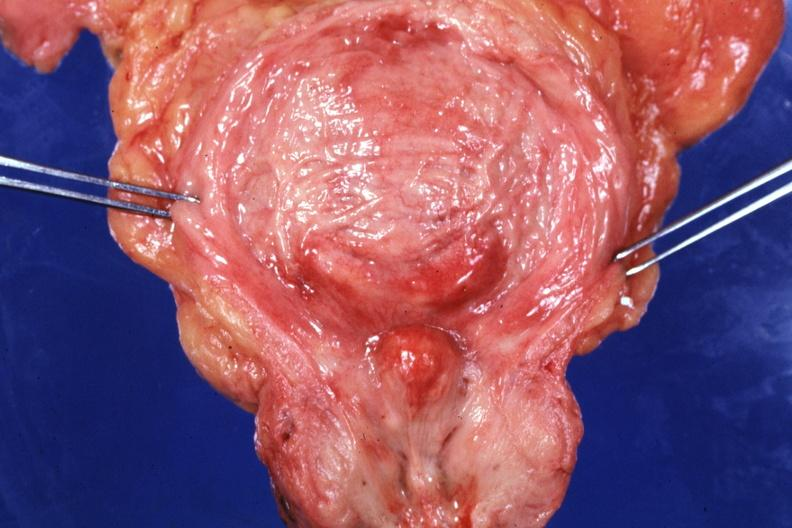what is present?
Answer the question using a single word or phrase. Benign hyperplasia 